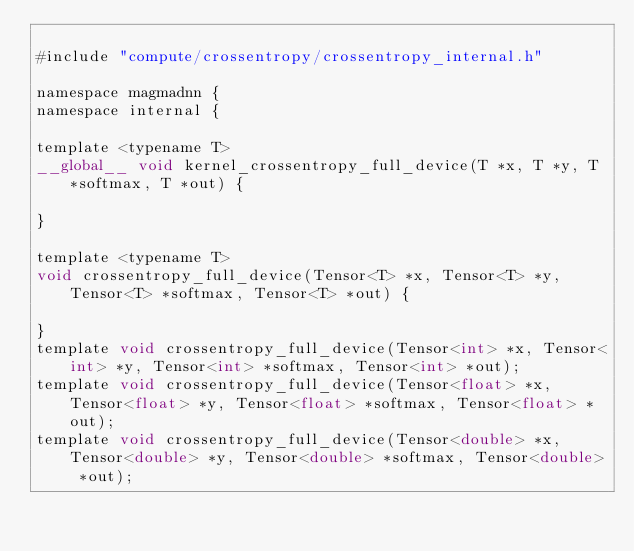<code> <loc_0><loc_0><loc_500><loc_500><_Cuda_>
#include "compute/crossentropy/crossentropy_internal.h"

namespace magmadnn {
namespace internal {
 
template <typename T>
__global__ void kernel_crossentropy_full_device(T *x, T *y, T *softmax, T *out) {

}

template <typename T>
void crossentropy_full_device(Tensor<T> *x, Tensor<T> *y, Tensor<T> *softmax, Tensor<T> *out) {

}
template void crossentropy_full_device(Tensor<int> *x, Tensor<int> *y, Tensor<int> *softmax, Tensor<int> *out);
template void crossentropy_full_device(Tensor<float> *x, Tensor<float> *y, Tensor<float> *softmax, Tensor<float> *out);
template void crossentropy_full_device(Tensor<double> *x, Tensor<double> *y, Tensor<double> *softmax, Tensor<double> *out);
 </code> 